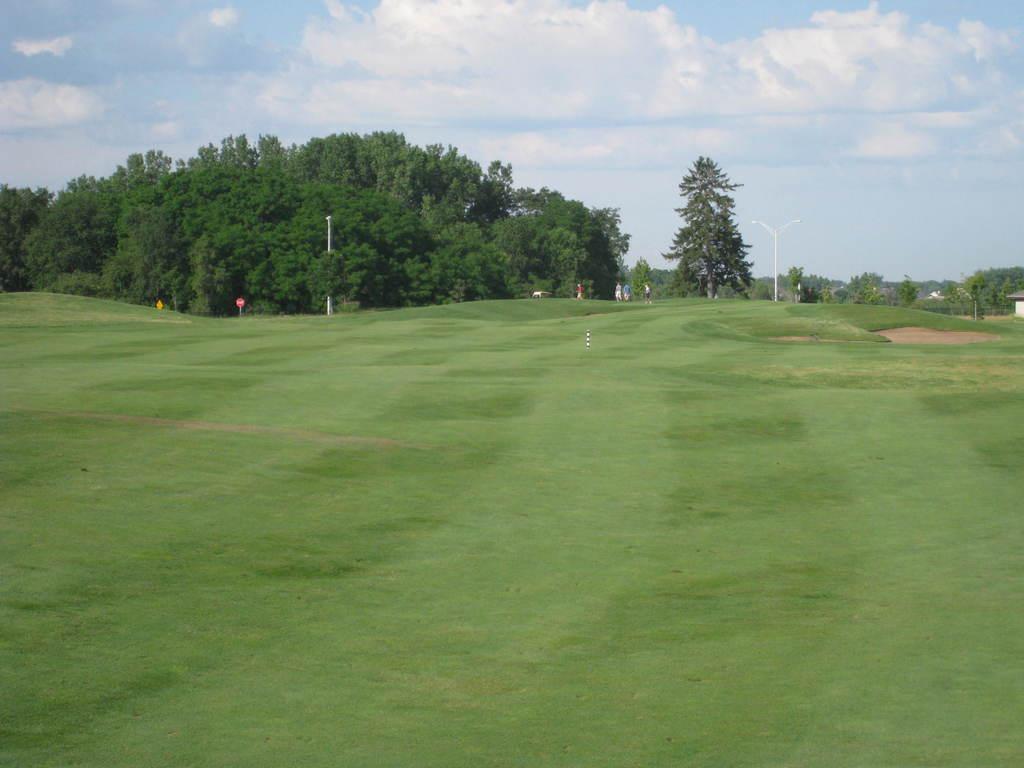In one or two sentences, can you explain what this image depicts? In this image, we can see the ground covered with grass. We can see some trees. There are a few poles. We can see a signboard. We can see some people. We can see the sky with clouds. 